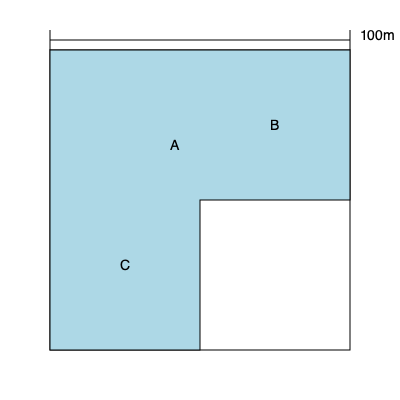Based on the aerial view of an irregularly shaped commercial property shown above, estimate its total square footage. The property is divided into three sections: A, B, and C. The width of the entire property is 100 meters. To estimate the total square footage, we'll break down the property into rectangular sections and calculate their areas:

1. Calculate the scale:
   The width is 100m, which corresponds to 300 pixels in the image.
   Scale: 1 pixel = 100m / 300 = 1/3 meter

2. Measure dimensions in pixels and convert to meters:
   - Section A: 150px x 150px = 50m x 50m
   - Section B: 150px x 150px = 50m x 50m
   - Section C: 150px x 150px = 50m x 50m

3. Calculate areas:
   - Area A = 50m x 50m = 2,500 sq m
   - Area B = 50m x 50m = 2,500 sq m
   - Area C = 50m x 50m = 2,500 sq m

4. Sum up the areas:
   Total Area = 2,500 + 2,500 + 2,500 = 7,500 sq m

5. Convert square meters to square feet:
   1 sq m ≈ 10.7639 sq ft
   Total Area in sq ft = 7,500 x 10.7639 ≈ 80,729 sq ft

Therefore, the estimated total square footage of the commercial property is approximately 80,729 sq ft.
Answer: 80,729 sq ft 